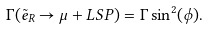Convert formula to latex. <formula><loc_0><loc_0><loc_500><loc_500>\Gamma ( \tilde { e } _ { R } \rightarrow \mu + L S P ) = \Gamma \sin ^ { 2 } ( \phi ) .</formula> 